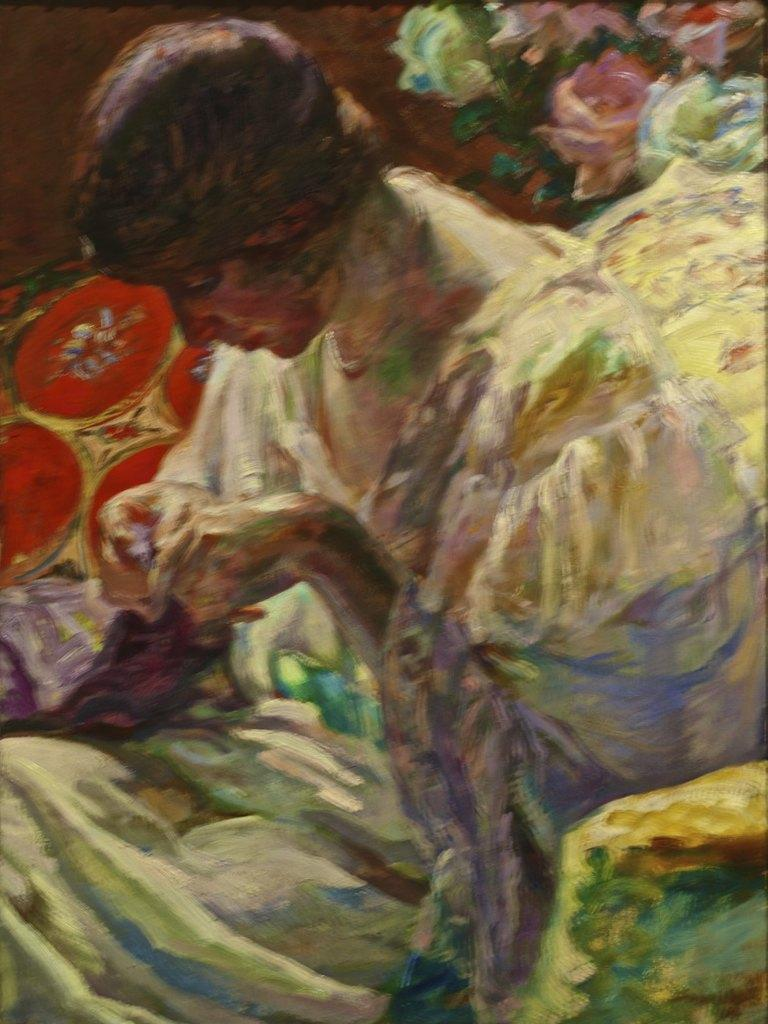What is the main subject of the image? There is a painting in the image. What is depicted in the painting? The painting depicts a person and flowers. What type of fish can be seen swimming in the painting? There are no fish present in the painting; it depicts a person and flowers. 